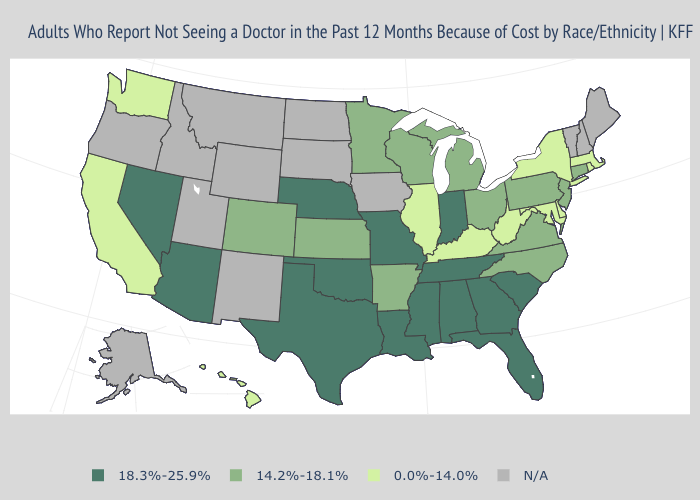Among the states that border Alabama , which have the lowest value?
Short answer required. Florida, Georgia, Mississippi, Tennessee. Does Kentucky have the lowest value in the USA?
Short answer required. Yes. Name the states that have a value in the range 14.2%-18.1%?
Quick response, please. Arkansas, Colorado, Connecticut, Kansas, Michigan, Minnesota, New Jersey, North Carolina, Ohio, Pennsylvania, Virginia, Wisconsin. Name the states that have a value in the range 18.3%-25.9%?
Give a very brief answer. Alabama, Arizona, Florida, Georgia, Indiana, Louisiana, Mississippi, Missouri, Nebraska, Nevada, Oklahoma, South Carolina, Tennessee, Texas. What is the value of Tennessee?
Answer briefly. 18.3%-25.9%. Does Indiana have the lowest value in the MidWest?
Be succinct. No. Which states have the lowest value in the USA?
Give a very brief answer. California, Delaware, Hawaii, Illinois, Kentucky, Maryland, Massachusetts, New York, Rhode Island, Washington, West Virginia. What is the value of Hawaii?
Write a very short answer. 0.0%-14.0%. Does the map have missing data?
Keep it brief. Yes. How many symbols are there in the legend?
Give a very brief answer. 4. Does Nebraska have the highest value in the MidWest?
Short answer required. Yes. 